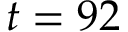<formula> <loc_0><loc_0><loc_500><loc_500>t = 9 2</formula> 